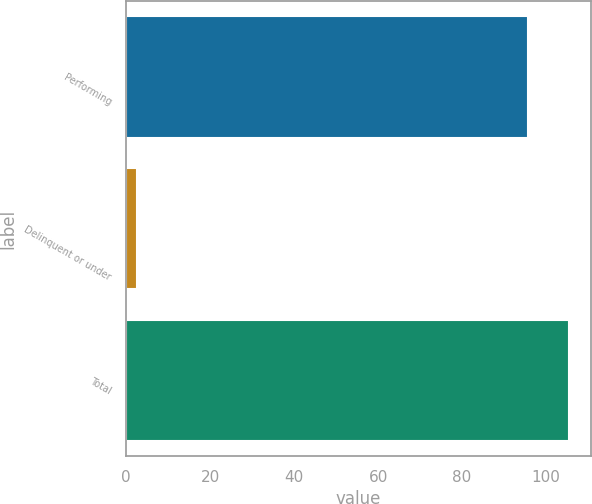Convert chart to OTSL. <chart><loc_0><loc_0><loc_500><loc_500><bar_chart><fcel>Performing<fcel>Delinquent or under<fcel>Total<nl><fcel>95.7<fcel>2.5<fcel>105.45<nl></chart> 